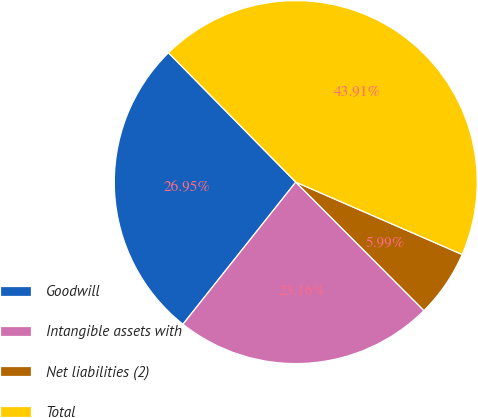Convert chart. <chart><loc_0><loc_0><loc_500><loc_500><pie_chart><fcel>Goodwill<fcel>Intangible assets with<fcel>Net liabilities (2)<fcel>Total<nl><fcel>26.95%<fcel>23.16%<fcel>5.99%<fcel>43.91%<nl></chart> 